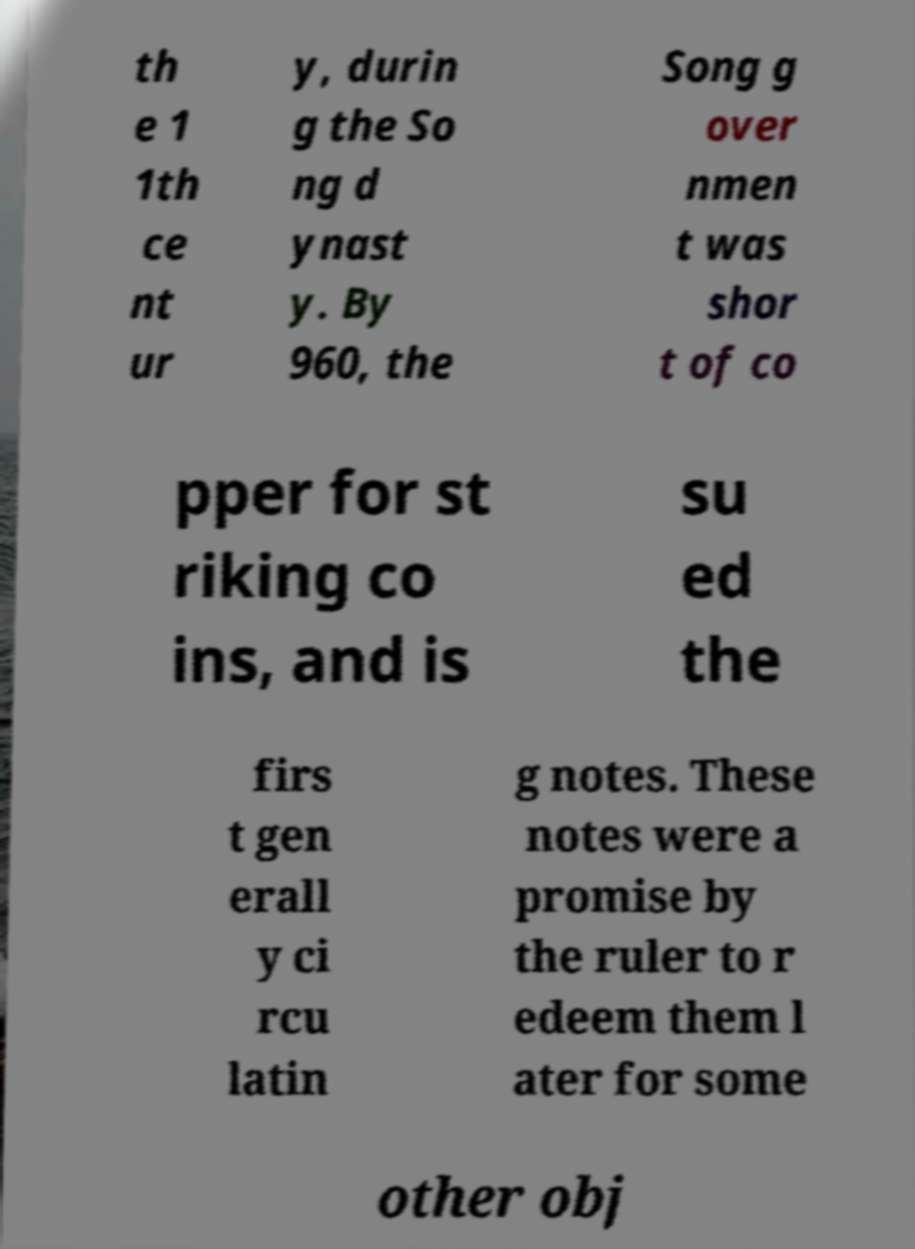Could you extract and type out the text from this image? th e 1 1th ce nt ur y, durin g the So ng d ynast y. By 960, the Song g over nmen t was shor t of co pper for st riking co ins, and is su ed the firs t gen erall y ci rcu latin g notes. These notes were a promise by the ruler to r edeem them l ater for some other obj 